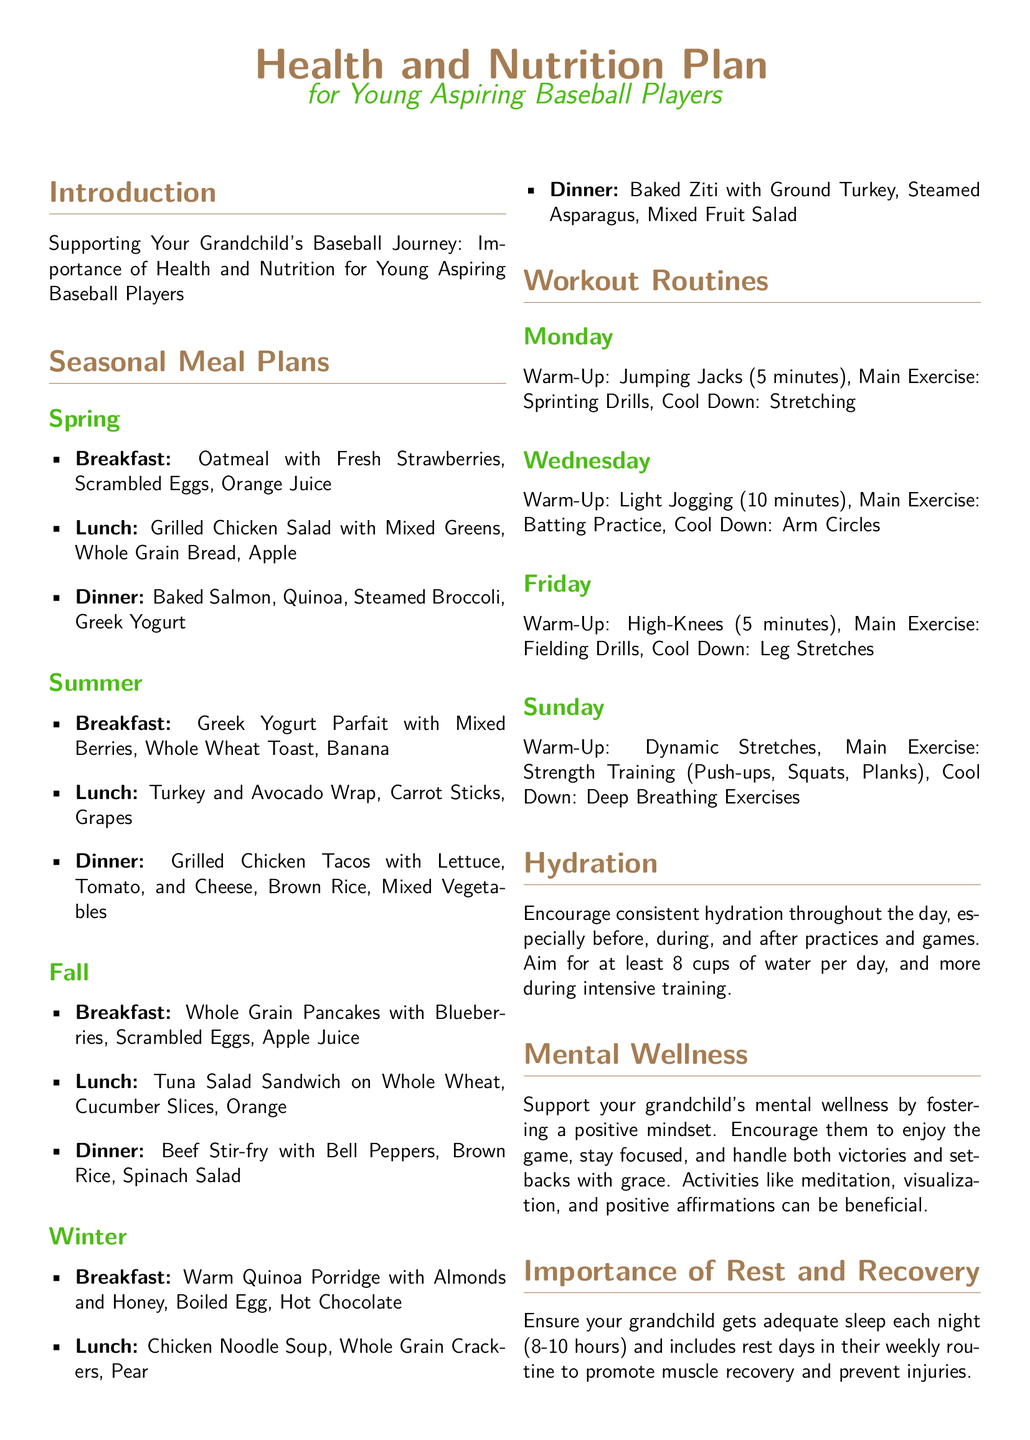what is a recommended breakfast for spring? The document lists "Oatmeal with Fresh Strawberries, Scrambled Eggs, Orange Juice" as the breakfast for spring.
Answer: Oatmeal with Fresh Strawberries, Scrambled Eggs, Orange Juice how many cups of water should be aimed for daily? The document suggests aiming for at least "8 cups" of water per day.
Answer: 8 cups which day includes strength training in the workout routine? The document specifies that "Sunday" is the day for strength training.
Answer: Sunday what is included in the summer lunch meal? The summer lunch consists of "Turkey and Avocado Wrap, Carrot Sticks, Grapes."
Answer: Turkey and Avocado Wrap, Carrot Sticks, Grapes how long should a young player sleep each night? The document recommends "8-10 hours" of sleep each night for adequate rest and recovery.
Answer: 8-10 hours what is covered in the Monday workout routine? The Monday workout includes "Sprinting Drills" as the main exercise.
Answer: Sprinting Drills what is emphasized for mental wellness? The document emphasizes fostering a "positive mindset" for mental wellness.
Answer: positive mindset which season has whole grain pancakes for breakfast? The document states that whole grain pancakes are listed for breakfast in the "Fall."
Answer: Fall what type of meal is dinner for winter? The winter dinner consists of "Baked Ziti with Ground Turkey, Steamed Asparagus, Mixed Fruit Salad."
Answer: Baked Ziti with Ground Turkey, Steamed Asparagus, Mixed Fruit Salad 